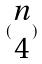Convert formula to latex. <formula><loc_0><loc_0><loc_500><loc_500>( \begin{matrix} n \\ 4 \end{matrix} )</formula> 